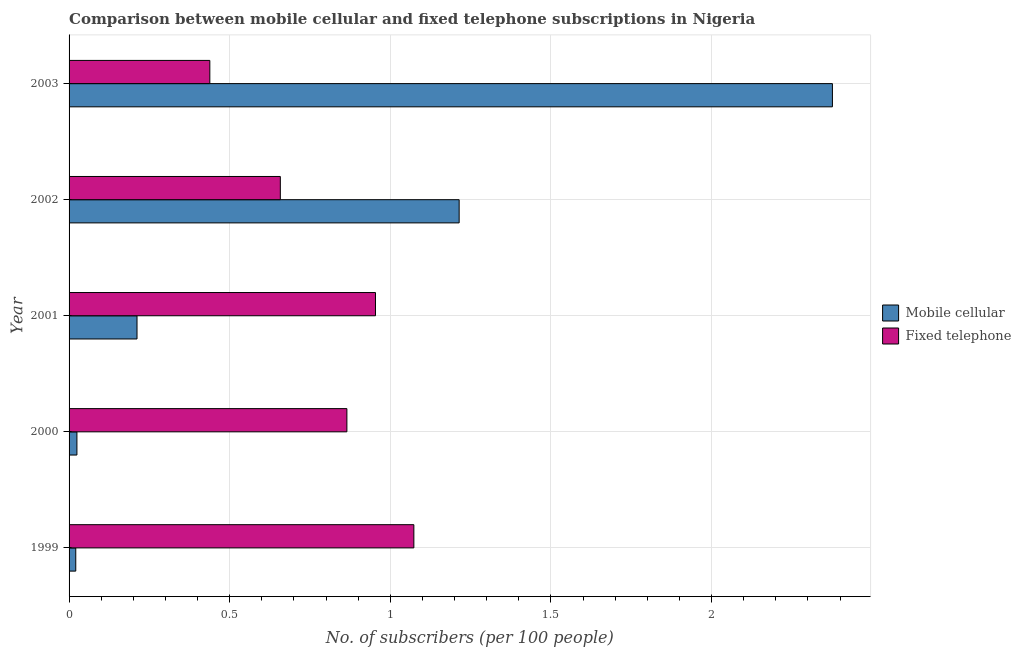How many groups of bars are there?
Your answer should be compact. 5. Are the number of bars on each tick of the Y-axis equal?
Offer a terse response. Yes. How many bars are there on the 4th tick from the top?
Your response must be concise. 2. How many bars are there on the 3rd tick from the bottom?
Provide a succinct answer. 2. What is the label of the 2nd group of bars from the top?
Make the answer very short. 2002. What is the number of mobile cellular subscribers in 2001?
Offer a terse response. 0.21. Across all years, what is the maximum number of mobile cellular subscribers?
Ensure brevity in your answer.  2.38. Across all years, what is the minimum number of fixed telephone subscribers?
Provide a succinct answer. 0.44. In which year was the number of fixed telephone subscribers minimum?
Your answer should be very brief. 2003. What is the total number of mobile cellular subscribers in the graph?
Your response must be concise. 3.85. What is the difference between the number of mobile cellular subscribers in 1999 and that in 2000?
Your response must be concise. -0. What is the difference between the number of fixed telephone subscribers in 1999 and the number of mobile cellular subscribers in 2000?
Ensure brevity in your answer.  1.05. What is the average number of fixed telephone subscribers per year?
Provide a succinct answer. 0.8. In the year 2000, what is the difference between the number of mobile cellular subscribers and number of fixed telephone subscribers?
Make the answer very short. -0.84. In how many years, is the number of mobile cellular subscribers greater than 1.6 ?
Ensure brevity in your answer.  1. What is the ratio of the number of mobile cellular subscribers in 1999 to that in 2001?
Your answer should be very brief. 0.1. Is the number of fixed telephone subscribers in 1999 less than that in 2000?
Keep it short and to the point. No. What is the difference between the highest and the second highest number of fixed telephone subscribers?
Provide a succinct answer. 0.12. What is the difference between the highest and the lowest number of mobile cellular subscribers?
Provide a short and direct response. 2.36. In how many years, is the number of mobile cellular subscribers greater than the average number of mobile cellular subscribers taken over all years?
Offer a terse response. 2. What does the 2nd bar from the top in 1999 represents?
Offer a very short reply. Mobile cellular. What does the 2nd bar from the bottom in 2002 represents?
Offer a terse response. Fixed telephone. Are all the bars in the graph horizontal?
Keep it short and to the point. Yes. How many years are there in the graph?
Provide a succinct answer. 5. Are the values on the major ticks of X-axis written in scientific E-notation?
Make the answer very short. No. Does the graph contain any zero values?
Your answer should be very brief. No. Where does the legend appear in the graph?
Offer a very short reply. Center right. How many legend labels are there?
Provide a short and direct response. 2. How are the legend labels stacked?
Your answer should be compact. Vertical. What is the title of the graph?
Provide a succinct answer. Comparison between mobile cellular and fixed telephone subscriptions in Nigeria. What is the label or title of the X-axis?
Give a very brief answer. No. of subscribers (per 100 people). What is the label or title of the Y-axis?
Ensure brevity in your answer.  Year. What is the No. of subscribers (per 100 people) in Mobile cellular in 1999?
Keep it short and to the point. 0.02. What is the No. of subscribers (per 100 people) in Fixed telephone in 1999?
Offer a terse response. 1.07. What is the No. of subscribers (per 100 people) of Mobile cellular in 2000?
Provide a short and direct response. 0.02. What is the No. of subscribers (per 100 people) of Fixed telephone in 2000?
Ensure brevity in your answer.  0.86. What is the No. of subscribers (per 100 people) in Mobile cellular in 2001?
Offer a terse response. 0.21. What is the No. of subscribers (per 100 people) of Fixed telephone in 2001?
Your answer should be compact. 0.95. What is the No. of subscribers (per 100 people) of Mobile cellular in 2002?
Offer a terse response. 1.21. What is the No. of subscribers (per 100 people) in Fixed telephone in 2002?
Offer a very short reply. 0.66. What is the No. of subscribers (per 100 people) in Mobile cellular in 2003?
Your answer should be compact. 2.38. What is the No. of subscribers (per 100 people) of Fixed telephone in 2003?
Your answer should be very brief. 0.44. Across all years, what is the maximum No. of subscribers (per 100 people) in Mobile cellular?
Offer a very short reply. 2.38. Across all years, what is the maximum No. of subscribers (per 100 people) of Fixed telephone?
Make the answer very short. 1.07. Across all years, what is the minimum No. of subscribers (per 100 people) in Mobile cellular?
Your answer should be compact. 0.02. Across all years, what is the minimum No. of subscribers (per 100 people) in Fixed telephone?
Offer a terse response. 0.44. What is the total No. of subscribers (per 100 people) of Mobile cellular in the graph?
Provide a short and direct response. 3.85. What is the total No. of subscribers (per 100 people) in Fixed telephone in the graph?
Your response must be concise. 3.99. What is the difference between the No. of subscribers (per 100 people) in Mobile cellular in 1999 and that in 2000?
Your answer should be compact. -0. What is the difference between the No. of subscribers (per 100 people) in Fixed telephone in 1999 and that in 2000?
Your answer should be compact. 0.21. What is the difference between the No. of subscribers (per 100 people) in Mobile cellular in 1999 and that in 2001?
Keep it short and to the point. -0.19. What is the difference between the No. of subscribers (per 100 people) of Fixed telephone in 1999 and that in 2001?
Give a very brief answer. 0.12. What is the difference between the No. of subscribers (per 100 people) of Mobile cellular in 1999 and that in 2002?
Ensure brevity in your answer.  -1.19. What is the difference between the No. of subscribers (per 100 people) of Fixed telephone in 1999 and that in 2002?
Ensure brevity in your answer.  0.42. What is the difference between the No. of subscribers (per 100 people) of Mobile cellular in 1999 and that in 2003?
Give a very brief answer. -2.36. What is the difference between the No. of subscribers (per 100 people) of Fixed telephone in 1999 and that in 2003?
Offer a terse response. 0.64. What is the difference between the No. of subscribers (per 100 people) of Mobile cellular in 2000 and that in 2001?
Provide a short and direct response. -0.19. What is the difference between the No. of subscribers (per 100 people) of Fixed telephone in 2000 and that in 2001?
Ensure brevity in your answer.  -0.09. What is the difference between the No. of subscribers (per 100 people) of Mobile cellular in 2000 and that in 2002?
Keep it short and to the point. -1.19. What is the difference between the No. of subscribers (per 100 people) in Fixed telephone in 2000 and that in 2002?
Provide a succinct answer. 0.21. What is the difference between the No. of subscribers (per 100 people) of Mobile cellular in 2000 and that in 2003?
Ensure brevity in your answer.  -2.35. What is the difference between the No. of subscribers (per 100 people) of Fixed telephone in 2000 and that in 2003?
Make the answer very short. 0.43. What is the difference between the No. of subscribers (per 100 people) of Mobile cellular in 2001 and that in 2002?
Give a very brief answer. -1. What is the difference between the No. of subscribers (per 100 people) in Fixed telephone in 2001 and that in 2002?
Provide a short and direct response. 0.3. What is the difference between the No. of subscribers (per 100 people) of Mobile cellular in 2001 and that in 2003?
Provide a succinct answer. -2.16. What is the difference between the No. of subscribers (per 100 people) of Fixed telephone in 2001 and that in 2003?
Ensure brevity in your answer.  0.52. What is the difference between the No. of subscribers (per 100 people) in Mobile cellular in 2002 and that in 2003?
Ensure brevity in your answer.  -1.16. What is the difference between the No. of subscribers (per 100 people) of Fixed telephone in 2002 and that in 2003?
Your answer should be compact. 0.22. What is the difference between the No. of subscribers (per 100 people) of Mobile cellular in 1999 and the No. of subscribers (per 100 people) of Fixed telephone in 2000?
Offer a very short reply. -0.84. What is the difference between the No. of subscribers (per 100 people) of Mobile cellular in 1999 and the No. of subscribers (per 100 people) of Fixed telephone in 2001?
Ensure brevity in your answer.  -0.93. What is the difference between the No. of subscribers (per 100 people) in Mobile cellular in 1999 and the No. of subscribers (per 100 people) in Fixed telephone in 2002?
Keep it short and to the point. -0.64. What is the difference between the No. of subscribers (per 100 people) in Mobile cellular in 1999 and the No. of subscribers (per 100 people) in Fixed telephone in 2003?
Make the answer very short. -0.42. What is the difference between the No. of subscribers (per 100 people) in Mobile cellular in 2000 and the No. of subscribers (per 100 people) in Fixed telephone in 2001?
Your answer should be very brief. -0.93. What is the difference between the No. of subscribers (per 100 people) of Mobile cellular in 2000 and the No. of subscribers (per 100 people) of Fixed telephone in 2002?
Provide a succinct answer. -0.63. What is the difference between the No. of subscribers (per 100 people) of Mobile cellular in 2000 and the No. of subscribers (per 100 people) of Fixed telephone in 2003?
Ensure brevity in your answer.  -0.41. What is the difference between the No. of subscribers (per 100 people) in Mobile cellular in 2001 and the No. of subscribers (per 100 people) in Fixed telephone in 2002?
Your answer should be compact. -0.45. What is the difference between the No. of subscribers (per 100 people) in Mobile cellular in 2001 and the No. of subscribers (per 100 people) in Fixed telephone in 2003?
Give a very brief answer. -0.23. What is the difference between the No. of subscribers (per 100 people) of Mobile cellular in 2002 and the No. of subscribers (per 100 people) of Fixed telephone in 2003?
Your answer should be compact. 0.78. What is the average No. of subscribers (per 100 people) in Mobile cellular per year?
Give a very brief answer. 0.77. What is the average No. of subscribers (per 100 people) of Fixed telephone per year?
Provide a succinct answer. 0.8. In the year 1999, what is the difference between the No. of subscribers (per 100 people) of Mobile cellular and No. of subscribers (per 100 people) of Fixed telephone?
Your answer should be very brief. -1.05. In the year 2000, what is the difference between the No. of subscribers (per 100 people) in Mobile cellular and No. of subscribers (per 100 people) in Fixed telephone?
Ensure brevity in your answer.  -0.84. In the year 2001, what is the difference between the No. of subscribers (per 100 people) of Mobile cellular and No. of subscribers (per 100 people) of Fixed telephone?
Ensure brevity in your answer.  -0.74. In the year 2002, what is the difference between the No. of subscribers (per 100 people) of Mobile cellular and No. of subscribers (per 100 people) of Fixed telephone?
Give a very brief answer. 0.56. In the year 2003, what is the difference between the No. of subscribers (per 100 people) in Mobile cellular and No. of subscribers (per 100 people) in Fixed telephone?
Provide a short and direct response. 1.94. What is the ratio of the No. of subscribers (per 100 people) of Mobile cellular in 1999 to that in 2000?
Offer a very short reply. 0.85. What is the ratio of the No. of subscribers (per 100 people) of Fixed telephone in 1999 to that in 2000?
Provide a succinct answer. 1.24. What is the ratio of the No. of subscribers (per 100 people) in Mobile cellular in 1999 to that in 2001?
Keep it short and to the point. 0.1. What is the ratio of the No. of subscribers (per 100 people) of Fixed telephone in 1999 to that in 2001?
Your answer should be very brief. 1.13. What is the ratio of the No. of subscribers (per 100 people) in Mobile cellular in 1999 to that in 2002?
Ensure brevity in your answer.  0.02. What is the ratio of the No. of subscribers (per 100 people) of Fixed telephone in 1999 to that in 2002?
Your answer should be very brief. 1.63. What is the ratio of the No. of subscribers (per 100 people) in Mobile cellular in 1999 to that in 2003?
Provide a short and direct response. 0.01. What is the ratio of the No. of subscribers (per 100 people) of Fixed telephone in 1999 to that in 2003?
Offer a very short reply. 2.45. What is the ratio of the No. of subscribers (per 100 people) in Mobile cellular in 2000 to that in 2001?
Keep it short and to the point. 0.12. What is the ratio of the No. of subscribers (per 100 people) in Fixed telephone in 2000 to that in 2001?
Your answer should be very brief. 0.91. What is the ratio of the No. of subscribers (per 100 people) in Mobile cellular in 2000 to that in 2002?
Ensure brevity in your answer.  0.02. What is the ratio of the No. of subscribers (per 100 people) of Fixed telephone in 2000 to that in 2002?
Make the answer very short. 1.32. What is the ratio of the No. of subscribers (per 100 people) of Mobile cellular in 2000 to that in 2003?
Ensure brevity in your answer.  0.01. What is the ratio of the No. of subscribers (per 100 people) of Fixed telephone in 2000 to that in 2003?
Offer a terse response. 1.97. What is the ratio of the No. of subscribers (per 100 people) of Mobile cellular in 2001 to that in 2002?
Your answer should be compact. 0.17. What is the ratio of the No. of subscribers (per 100 people) of Fixed telephone in 2001 to that in 2002?
Ensure brevity in your answer.  1.45. What is the ratio of the No. of subscribers (per 100 people) of Mobile cellular in 2001 to that in 2003?
Make the answer very short. 0.09. What is the ratio of the No. of subscribers (per 100 people) of Fixed telephone in 2001 to that in 2003?
Make the answer very short. 2.18. What is the ratio of the No. of subscribers (per 100 people) in Mobile cellular in 2002 to that in 2003?
Your answer should be compact. 0.51. What is the ratio of the No. of subscribers (per 100 people) in Fixed telephone in 2002 to that in 2003?
Offer a terse response. 1.5. What is the difference between the highest and the second highest No. of subscribers (per 100 people) in Mobile cellular?
Your answer should be very brief. 1.16. What is the difference between the highest and the second highest No. of subscribers (per 100 people) of Fixed telephone?
Your response must be concise. 0.12. What is the difference between the highest and the lowest No. of subscribers (per 100 people) in Mobile cellular?
Your answer should be compact. 2.36. What is the difference between the highest and the lowest No. of subscribers (per 100 people) of Fixed telephone?
Offer a terse response. 0.64. 